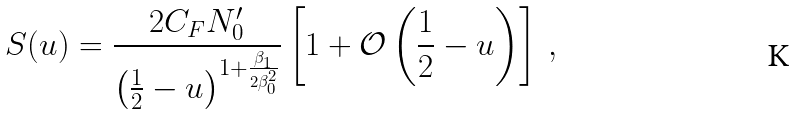<formula> <loc_0><loc_0><loc_500><loc_500>S ( u ) = \frac { 2 C _ { F } N _ { 0 } ^ { \prime } } { \left ( \frac { 1 } { 2 } - u \right ) ^ { 1 + \frac { \beta _ { 1 } } { 2 \beta _ { 0 } ^ { 2 } } } } \left [ 1 + \mathcal { O } \left ( \frac { 1 } { 2 } - u \right ) \right ] \, ,</formula> 